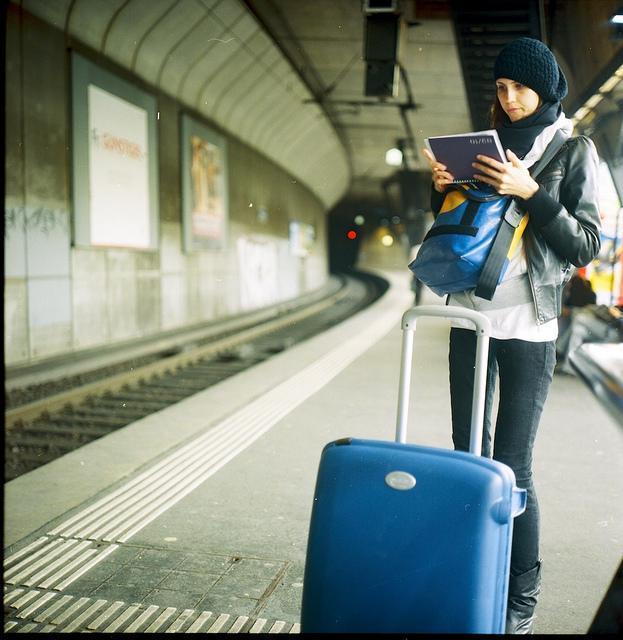What is the best luggage brand in the world?
Select the correct answer and articulate reasoning with the following format: 'Answer: answer
Rationale: rationale.'
Options: Rimowa, samsonite, delsey, away. Answer: away.
Rationale: The away is widely known to be the best. 